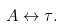<formula> <loc_0><loc_0><loc_500><loc_500>A \leftrightarrow \tau .</formula> 